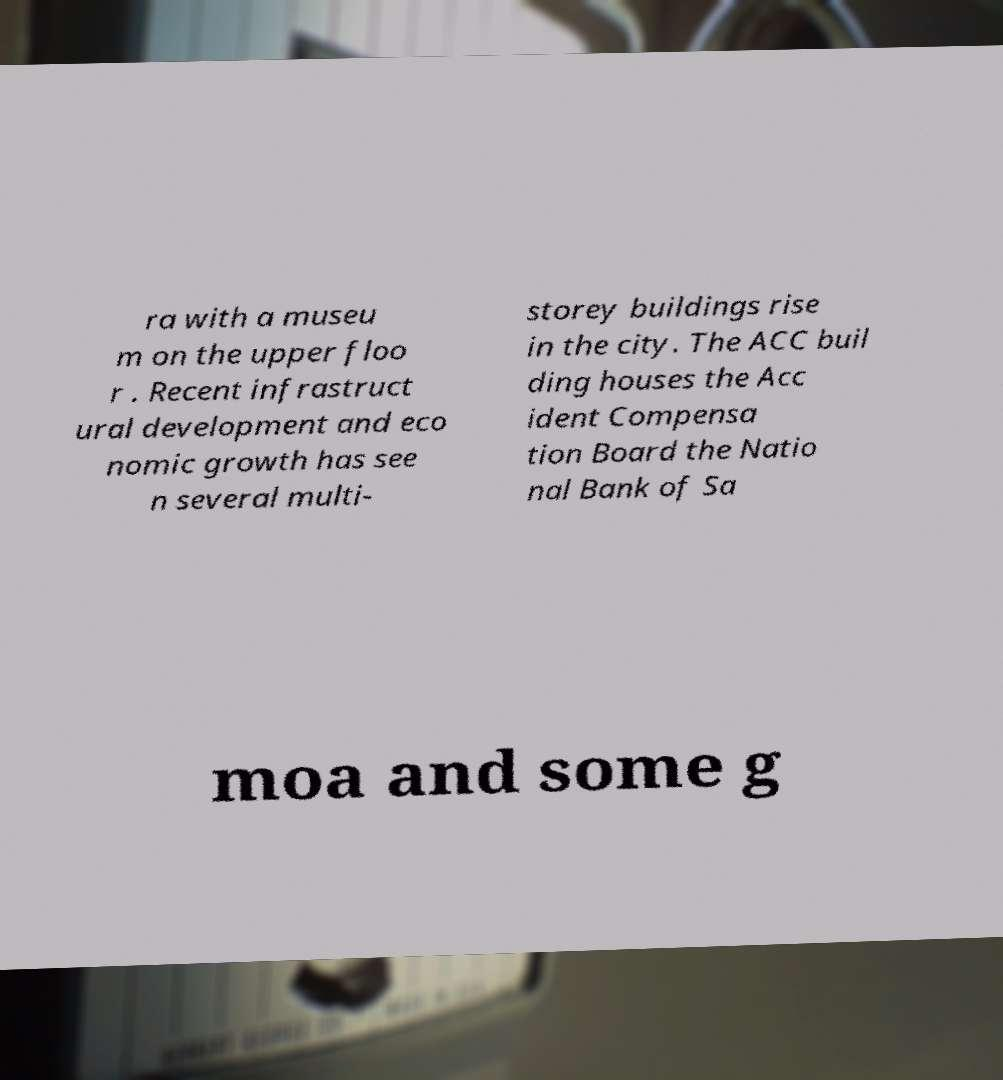What messages or text are displayed in this image? I need them in a readable, typed format. ra with a museu m on the upper floo r . Recent infrastruct ural development and eco nomic growth has see n several multi- storey buildings rise in the city. The ACC buil ding houses the Acc ident Compensa tion Board the Natio nal Bank of Sa moa and some g 